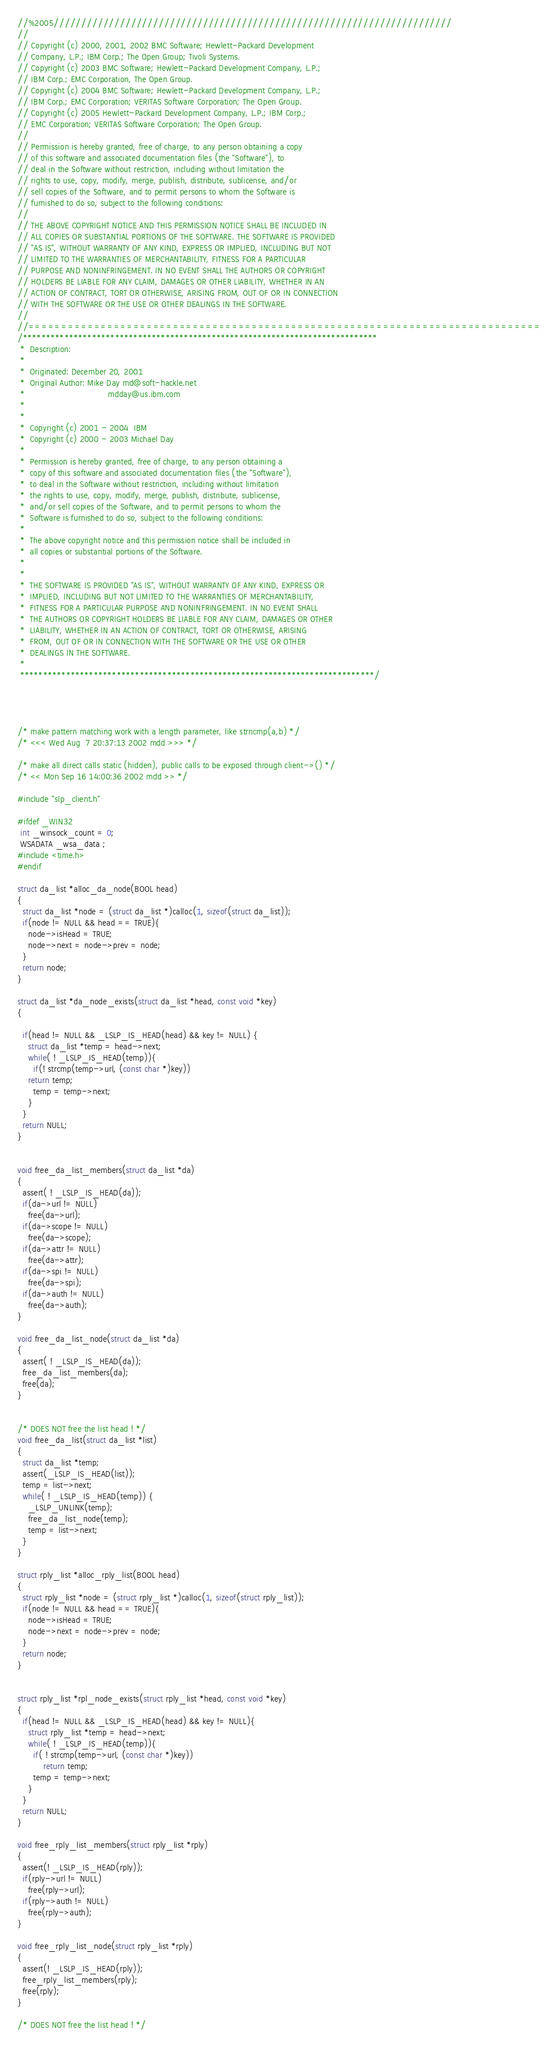<code> <loc_0><loc_0><loc_500><loc_500><_C++_>//%2005////////////////////////////////////////////////////////////////////////
//
// Copyright (c) 2000, 2001, 2002 BMC Software; Hewlett-Packard Development
// Company, L.P.; IBM Corp.; The Open Group; Tivoli Systems.
// Copyright (c) 2003 BMC Software; Hewlett-Packard Development Company, L.P.;
// IBM Corp.; EMC Corporation, The Open Group.
// Copyright (c) 2004 BMC Software; Hewlett-Packard Development Company, L.P.;
// IBM Corp.; EMC Corporation; VERITAS Software Corporation; The Open Group.
// Copyright (c) 2005 Hewlett-Packard Development Company, L.P.; IBM Corp.;
// EMC Corporation; VERITAS Software Corporation; The Open Group.
//
// Permission is hereby granted, free of charge, to any person obtaining a copy
// of this software and associated documentation files (the "Software"), to
// deal in the Software without restriction, including without limitation the
// rights to use, copy, modify, merge, publish, distribute, sublicense, and/or
// sell copies of the Software, and to permit persons to whom the Software is
// furnished to do so, subject to the following conditions:
// 
// THE ABOVE COPYRIGHT NOTICE AND THIS PERMISSION NOTICE SHALL BE INCLUDED IN
// ALL COPIES OR SUBSTANTIAL PORTIONS OF THE SOFTWARE. THE SOFTWARE IS PROVIDED
// "AS IS", WITHOUT WARRANTY OF ANY KIND, EXPRESS OR IMPLIED, INCLUDING BUT NOT
// LIMITED TO THE WARRANTIES OF MERCHANTABILITY, FITNESS FOR A PARTICULAR
// PURPOSE AND NONINFRINGEMENT. IN NO EVENT SHALL THE AUTHORS OR COPYRIGHT
// HOLDERS BE LIABLE FOR ANY CLAIM, DAMAGES OR OTHER LIABILITY, WHETHER IN AN
// ACTION OF CONTRACT, TORT OR OTHERWISE, ARISING FROM, OUT OF OR IN CONNECTION
// WITH THE SOFTWARE OR THE USE OR OTHER DEALINGS IN THE SOFTWARE.
//
//==============================================================================
/*****************************************************************************
 *  Description:
 *
 *  Originated: December 20, 2001
 *	Original Author: Mike Day md@soft-hackle.net
 *                                mdday@us.ibm.com
 *
 *               					
 *  Copyright (c) 2001 - 2004  IBM
 *  Copyright (c) 2000 - 2003 Michael Day
 *
 *  Permission is hereby granted, free of charge, to any person obtaining a
 *  copy of this software and associated documentation files (the "Software"),
 *  to deal in the Software without restriction, including without limitation
 *  the rights to use, copy, modify, merge, publish, distribute, sublicense,
 *  and/or sell copies of the Software, and to permit persons to whom the
 *  Software is furnished to do so, subject to the following conditions:
 *
 *  The above copyright notice and this permission notice shall be included in
 *  all copies or substantial portions of the Software.
 *
 *
 *  THE SOFTWARE IS PROVIDED "AS IS", WITHOUT WARRANTY OF ANY KIND, EXPRESS OR
 *  IMPLIED, INCLUDING BUT NOT LIMITED TO THE WARRANTIES OF MERCHANTABILITY,
 *  FITNESS FOR A PARTICULAR PURPOSE AND NONINFRINGEMENT. IN NO EVENT SHALL
 *  THE AUTHORS OR COPYRIGHT HOLDERS BE LIABLE FOR ANY CLAIM, DAMAGES OR OTHER
 *  LIABILITY, WHETHER IN AN ACTION OF CONTRACT, TORT OR OTHERWISE, ARISING
 *  FROM, OUT OF OR IN CONNECTION WITH THE SOFTWARE OR THE USE OR OTHER
 *  DEALINGS IN THE SOFTWARE.
 *
 *****************************************************************************/




/* make pattern matching work with a length parameter, like strncmp(a,b) */
/* <<< Wed Aug  7 20:37:13 2002 mdd >>> */

/* make all direct calls static (hidden), public calls to be exposed through client->() */
/* << Mon Sep 16 14:00:36 2002 mdd >> */

#include "slp_client.h"

#ifdef _WIN32
 int _winsock_count = 0;
 WSADATA _wsa_data ;
#include <time.h>
#endif

struct da_list *alloc_da_node(BOOL head)
{
  struct da_list *node = (struct da_list *)calloc(1, sizeof(struct da_list));
  if(node != NULL && head == TRUE){
    node->isHead = TRUE;
    node->next = node->prev = node;
  }
  return node;
}

struct da_list *da_node_exists(struct da_list *head, const void *key)
{

  if(head != NULL && _LSLP_IS_HEAD(head) && key != NULL) {
    struct da_list *temp = head->next;
    while( ! _LSLP_IS_HEAD(temp)){
      if(! strcmp(temp->url, (const char *)key))
	return temp;
      temp = temp->next;
    }
  }
  return NULL;
}


void free_da_list_members(struct da_list *da)
{
  assert( ! _LSLP_IS_HEAD(da));
  if(da->url != NULL)
    free(da->url);
  if(da->scope != NULL)
    free(da->scope);
  if(da->attr != NULL)
    free(da->attr);
  if(da->spi != NULL)
    free(da->spi);
  if(da->auth != NULL)
    free(da->auth);
}

void free_da_list_node(struct da_list *da)
{
  assert( ! _LSLP_IS_HEAD(da));
  free_da_list_members(da);
  free(da);
}


/* DOES NOT free the list head ! */
void free_da_list(struct da_list *list)
{
  struct da_list *temp;
  assert(_LSLP_IS_HEAD(list));
  temp = list->next;
  while( ! _LSLP_IS_HEAD(temp)) {
    _LSLP_UNLINK(temp);
    free_da_list_node(temp);
    temp = list->next;
  }
}

struct rply_list *alloc_rply_list(BOOL head)
{
  struct rply_list *node = (struct rply_list *)calloc(1, sizeof(struct rply_list));
  if(node != NULL && head == TRUE){
    node->isHead = TRUE;
    node->next = node->prev = node;
  }
  return node;
}


struct rply_list *rpl_node_exists(struct rply_list *head, const void *key)
{
  if(head != NULL && _LSLP_IS_HEAD(head) && key != NULL){
    struct rply_list *temp = head->next;
    while( ! _LSLP_IS_HEAD(temp)){
      if( ! strcmp(temp->url, (const char *)key))
          return temp;
      temp = temp->next;
    }
  }
  return NULL;
}

void free_rply_list_members(struct rply_list *rply)
{
  assert(! _LSLP_IS_HEAD(rply));
  if(rply->url != NULL)
    free(rply->url);
  if(rply->auth != NULL)
    free(rply->auth);
}

void free_rply_list_node(struct rply_list *rply)
{
  assert(! _LSLP_IS_HEAD(rply));
  free_rply_list_members(rply);
  free(rply);
}

/* DOES NOT free the list head ! */</code> 